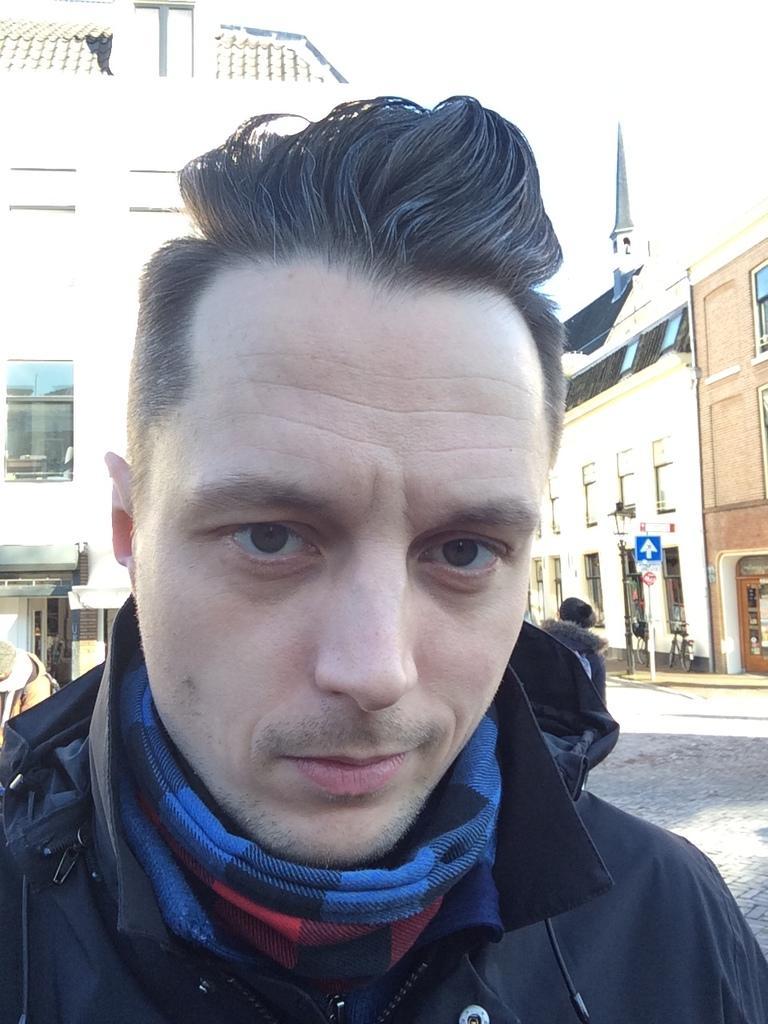Could you give a brief overview of what you see in this image? This image consists of a man wearing black jackets and scarf. In the background, there are buildings along with windows. At the bottom, there is road. To the top, there is sky. 